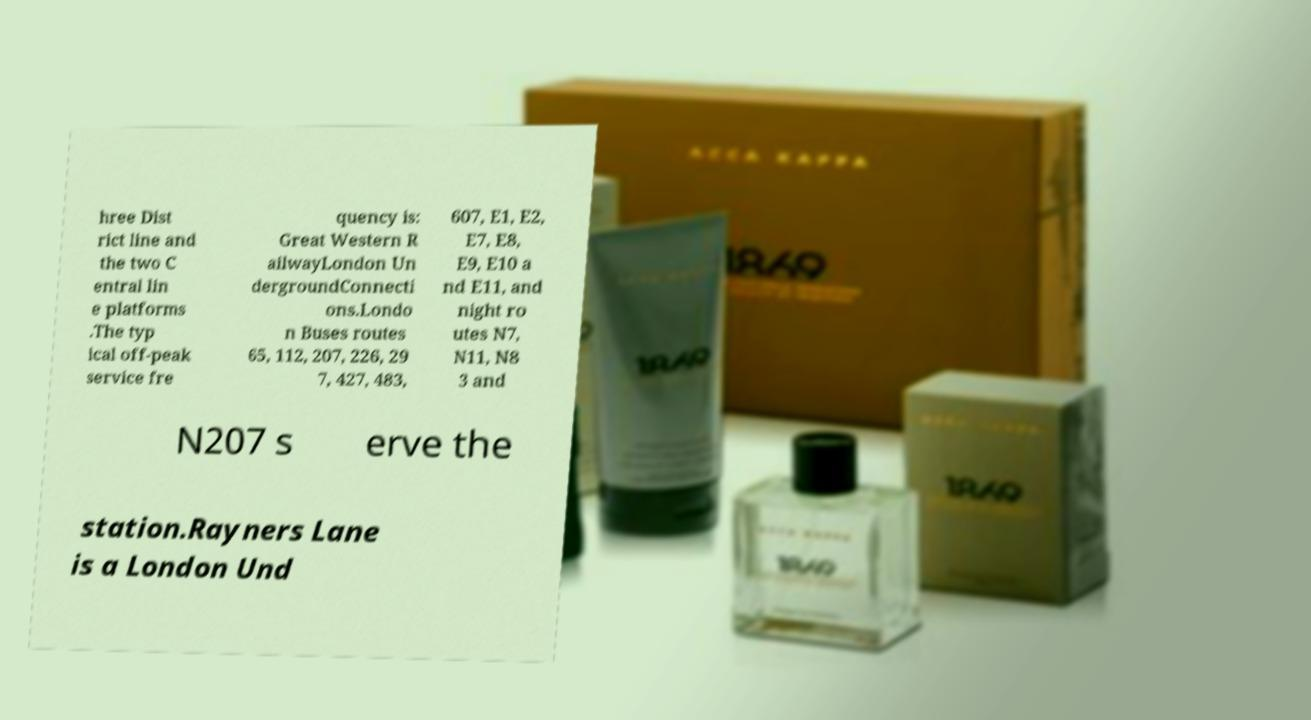Could you assist in decoding the text presented in this image and type it out clearly? hree Dist rict line and the two C entral lin e platforms .The typ ical off-peak service fre quency is: Great Western R ailwayLondon Un dergroundConnecti ons.Londo n Buses routes 65, 112, 207, 226, 29 7, 427, 483, 607, E1, E2, E7, E8, E9, E10 a nd E11, and night ro utes N7, N11, N8 3 and N207 s erve the station.Rayners Lane is a London Und 